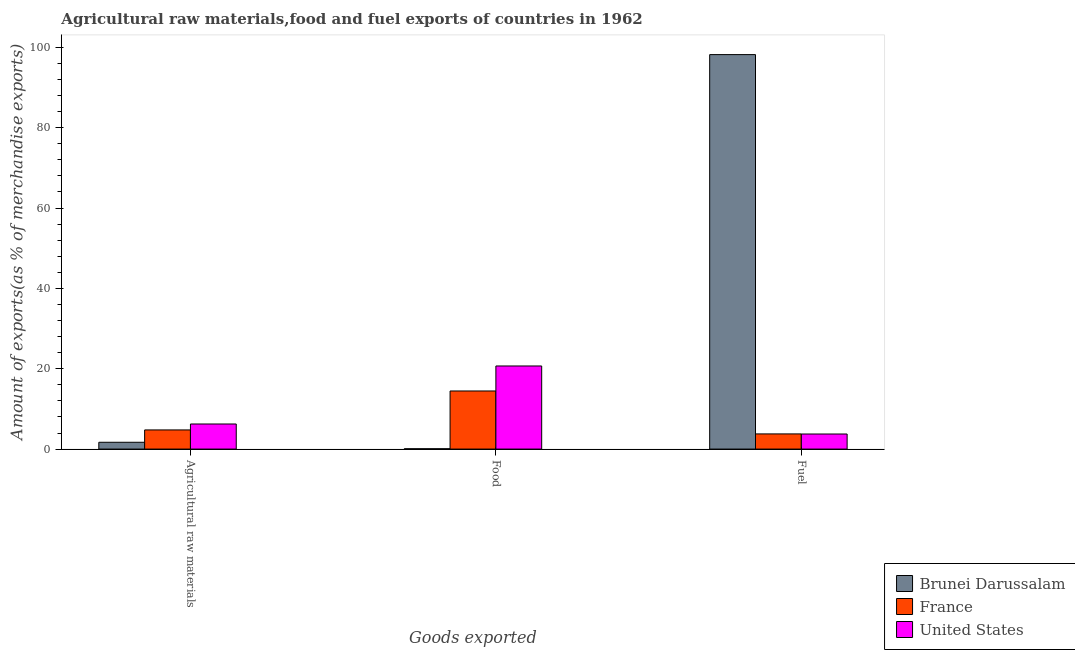Are the number of bars per tick equal to the number of legend labels?
Your response must be concise. Yes. Are the number of bars on each tick of the X-axis equal?
Your answer should be compact. Yes. What is the label of the 2nd group of bars from the left?
Provide a succinct answer. Food. What is the percentage of food exports in United States?
Give a very brief answer. 20.68. Across all countries, what is the maximum percentage of raw materials exports?
Make the answer very short. 6.24. Across all countries, what is the minimum percentage of fuel exports?
Make the answer very short. 3.75. In which country was the percentage of raw materials exports maximum?
Give a very brief answer. United States. What is the total percentage of fuel exports in the graph?
Provide a succinct answer. 105.72. What is the difference between the percentage of fuel exports in France and that in Brunei Darussalam?
Ensure brevity in your answer.  -94.42. What is the difference between the percentage of raw materials exports in Brunei Darussalam and the percentage of fuel exports in France?
Offer a very short reply. -2.08. What is the average percentage of raw materials exports per country?
Keep it short and to the point. 4.23. What is the difference between the percentage of fuel exports and percentage of raw materials exports in Brunei Darussalam?
Your answer should be very brief. 96.5. What is the ratio of the percentage of raw materials exports in United States to that in Brunei Darussalam?
Your response must be concise. 3.69. Is the percentage of fuel exports in United States less than that in France?
Your response must be concise. Yes. What is the difference between the highest and the second highest percentage of fuel exports?
Your answer should be compact. 94.42. What is the difference between the highest and the lowest percentage of raw materials exports?
Provide a succinct answer. 4.55. In how many countries, is the percentage of raw materials exports greater than the average percentage of raw materials exports taken over all countries?
Provide a succinct answer. 2. What does the 3rd bar from the left in Food represents?
Provide a short and direct response. United States. Does the graph contain any zero values?
Keep it short and to the point. No. Does the graph contain grids?
Keep it short and to the point. No. Where does the legend appear in the graph?
Your answer should be very brief. Bottom right. How are the legend labels stacked?
Offer a terse response. Vertical. What is the title of the graph?
Give a very brief answer. Agricultural raw materials,food and fuel exports of countries in 1962. What is the label or title of the X-axis?
Offer a terse response. Goods exported. What is the label or title of the Y-axis?
Your response must be concise. Amount of exports(as % of merchandise exports). What is the Amount of exports(as % of merchandise exports) in Brunei Darussalam in Agricultural raw materials?
Provide a succinct answer. 1.69. What is the Amount of exports(as % of merchandise exports) of France in Agricultural raw materials?
Your answer should be very brief. 4.77. What is the Amount of exports(as % of merchandise exports) in United States in Agricultural raw materials?
Offer a very short reply. 6.24. What is the Amount of exports(as % of merchandise exports) in Brunei Darussalam in Food?
Keep it short and to the point. 0.08. What is the Amount of exports(as % of merchandise exports) of France in Food?
Give a very brief answer. 14.46. What is the Amount of exports(as % of merchandise exports) of United States in Food?
Provide a short and direct response. 20.68. What is the Amount of exports(as % of merchandise exports) in Brunei Darussalam in Fuel?
Keep it short and to the point. 98.2. What is the Amount of exports(as % of merchandise exports) in France in Fuel?
Keep it short and to the point. 3.78. What is the Amount of exports(as % of merchandise exports) of United States in Fuel?
Make the answer very short. 3.75. Across all Goods exported, what is the maximum Amount of exports(as % of merchandise exports) in Brunei Darussalam?
Your response must be concise. 98.2. Across all Goods exported, what is the maximum Amount of exports(as % of merchandise exports) in France?
Give a very brief answer. 14.46. Across all Goods exported, what is the maximum Amount of exports(as % of merchandise exports) of United States?
Make the answer very short. 20.68. Across all Goods exported, what is the minimum Amount of exports(as % of merchandise exports) of Brunei Darussalam?
Your answer should be compact. 0.08. Across all Goods exported, what is the minimum Amount of exports(as % of merchandise exports) of France?
Offer a terse response. 3.78. Across all Goods exported, what is the minimum Amount of exports(as % of merchandise exports) in United States?
Provide a succinct answer. 3.75. What is the total Amount of exports(as % of merchandise exports) of Brunei Darussalam in the graph?
Keep it short and to the point. 99.97. What is the total Amount of exports(as % of merchandise exports) in France in the graph?
Your answer should be very brief. 23.01. What is the total Amount of exports(as % of merchandise exports) of United States in the graph?
Offer a terse response. 30.68. What is the difference between the Amount of exports(as % of merchandise exports) in Brunei Darussalam in Agricultural raw materials and that in Food?
Offer a very short reply. 1.61. What is the difference between the Amount of exports(as % of merchandise exports) of France in Agricultural raw materials and that in Food?
Provide a short and direct response. -9.7. What is the difference between the Amount of exports(as % of merchandise exports) of United States in Agricultural raw materials and that in Food?
Give a very brief answer. -14.44. What is the difference between the Amount of exports(as % of merchandise exports) in Brunei Darussalam in Agricultural raw materials and that in Fuel?
Provide a short and direct response. -96.5. What is the difference between the Amount of exports(as % of merchandise exports) in United States in Agricultural raw materials and that in Fuel?
Offer a terse response. 2.49. What is the difference between the Amount of exports(as % of merchandise exports) of Brunei Darussalam in Food and that in Fuel?
Keep it short and to the point. -98.12. What is the difference between the Amount of exports(as % of merchandise exports) in France in Food and that in Fuel?
Your answer should be compact. 10.69. What is the difference between the Amount of exports(as % of merchandise exports) of United States in Food and that in Fuel?
Make the answer very short. 16.93. What is the difference between the Amount of exports(as % of merchandise exports) of Brunei Darussalam in Agricultural raw materials and the Amount of exports(as % of merchandise exports) of France in Food?
Provide a short and direct response. -12.77. What is the difference between the Amount of exports(as % of merchandise exports) in Brunei Darussalam in Agricultural raw materials and the Amount of exports(as % of merchandise exports) in United States in Food?
Provide a succinct answer. -18.99. What is the difference between the Amount of exports(as % of merchandise exports) in France in Agricultural raw materials and the Amount of exports(as % of merchandise exports) in United States in Food?
Keep it short and to the point. -15.92. What is the difference between the Amount of exports(as % of merchandise exports) in Brunei Darussalam in Agricultural raw materials and the Amount of exports(as % of merchandise exports) in France in Fuel?
Your response must be concise. -2.08. What is the difference between the Amount of exports(as % of merchandise exports) in Brunei Darussalam in Agricultural raw materials and the Amount of exports(as % of merchandise exports) in United States in Fuel?
Your answer should be compact. -2.06. What is the difference between the Amount of exports(as % of merchandise exports) in France in Agricultural raw materials and the Amount of exports(as % of merchandise exports) in United States in Fuel?
Give a very brief answer. 1.02. What is the difference between the Amount of exports(as % of merchandise exports) in Brunei Darussalam in Food and the Amount of exports(as % of merchandise exports) in France in Fuel?
Make the answer very short. -3.7. What is the difference between the Amount of exports(as % of merchandise exports) of Brunei Darussalam in Food and the Amount of exports(as % of merchandise exports) of United States in Fuel?
Your answer should be very brief. -3.67. What is the difference between the Amount of exports(as % of merchandise exports) in France in Food and the Amount of exports(as % of merchandise exports) in United States in Fuel?
Provide a short and direct response. 10.71. What is the average Amount of exports(as % of merchandise exports) of Brunei Darussalam per Goods exported?
Your response must be concise. 33.32. What is the average Amount of exports(as % of merchandise exports) of France per Goods exported?
Offer a very short reply. 7.67. What is the average Amount of exports(as % of merchandise exports) in United States per Goods exported?
Give a very brief answer. 10.23. What is the difference between the Amount of exports(as % of merchandise exports) of Brunei Darussalam and Amount of exports(as % of merchandise exports) of France in Agricultural raw materials?
Ensure brevity in your answer.  -3.07. What is the difference between the Amount of exports(as % of merchandise exports) of Brunei Darussalam and Amount of exports(as % of merchandise exports) of United States in Agricultural raw materials?
Offer a very short reply. -4.55. What is the difference between the Amount of exports(as % of merchandise exports) in France and Amount of exports(as % of merchandise exports) in United States in Agricultural raw materials?
Give a very brief answer. -1.48. What is the difference between the Amount of exports(as % of merchandise exports) of Brunei Darussalam and Amount of exports(as % of merchandise exports) of France in Food?
Your answer should be very brief. -14.39. What is the difference between the Amount of exports(as % of merchandise exports) in Brunei Darussalam and Amount of exports(as % of merchandise exports) in United States in Food?
Ensure brevity in your answer.  -20.61. What is the difference between the Amount of exports(as % of merchandise exports) in France and Amount of exports(as % of merchandise exports) in United States in Food?
Offer a very short reply. -6.22. What is the difference between the Amount of exports(as % of merchandise exports) of Brunei Darussalam and Amount of exports(as % of merchandise exports) of France in Fuel?
Offer a terse response. 94.42. What is the difference between the Amount of exports(as % of merchandise exports) in Brunei Darussalam and Amount of exports(as % of merchandise exports) in United States in Fuel?
Keep it short and to the point. 94.44. What is the difference between the Amount of exports(as % of merchandise exports) in France and Amount of exports(as % of merchandise exports) in United States in Fuel?
Provide a short and direct response. 0.02. What is the ratio of the Amount of exports(as % of merchandise exports) in Brunei Darussalam in Agricultural raw materials to that in Food?
Ensure brevity in your answer.  21.55. What is the ratio of the Amount of exports(as % of merchandise exports) of France in Agricultural raw materials to that in Food?
Keep it short and to the point. 0.33. What is the ratio of the Amount of exports(as % of merchandise exports) of United States in Agricultural raw materials to that in Food?
Ensure brevity in your answer.  0.3. What is the ratio of the Amount of exports(as % of merchandise exports) in Brunei Darussalam in Agricultural raw materials to that in Fuel?
Make the answer very short. 0.02. What is the ratio of the Amount of exports(as % of merchandise exports) of France in Agricultural raw materials to that in Fuel?
Make the answer very short. 1.26. What is the ratio of the Amount of exports(as % of merchandise exports) of United States in Agricultural raw materials to that in Fuel?
Give a very brief answer. 1.66. What is the ratio of the Amount of exports(as % of merchandise exports) in Brunei Darussalam in Food to that in Fuel?
Provide a succinct answer. 0. What is the ratio of the Amount of exports(as % of merchandise exports) of France in Food to that in Fuel?
Your answer should be compact. 3.83. What is the ratio of the Amount of exports(as % of merchandise exports) of United States in Food to that in Fuel?
Your response must be concise. 5.51. What is the difference between the highest and the second highest Amount of exports(as % of merchandise exports) in Brunei Darussalam?
Your response must be concise. 96.5. What is the difference between the highest and the second highest Amount of exports(as % of merchandise exports) in France?
Make the answer very short. 9.7. What is the difference between the highest and the second highest Amount of exports(as % of merchandise exports) of United States?
Ensure brevity in your answer.  14.44. What is the difference between the highest and the lowest Amount of exports(as % of merchandise exports) of Brunei Darussalam?
Offer a very short reply. 98.12. What is the difference between the highest and the lowest Amount of exports(as % of merchandise exports) of France?
Give a very brief answer. 10.69. What is the difference between the highest and the lowest Amount of exports(as % of merchandise exports) of United States?
Offer a terse response. 16.93. 